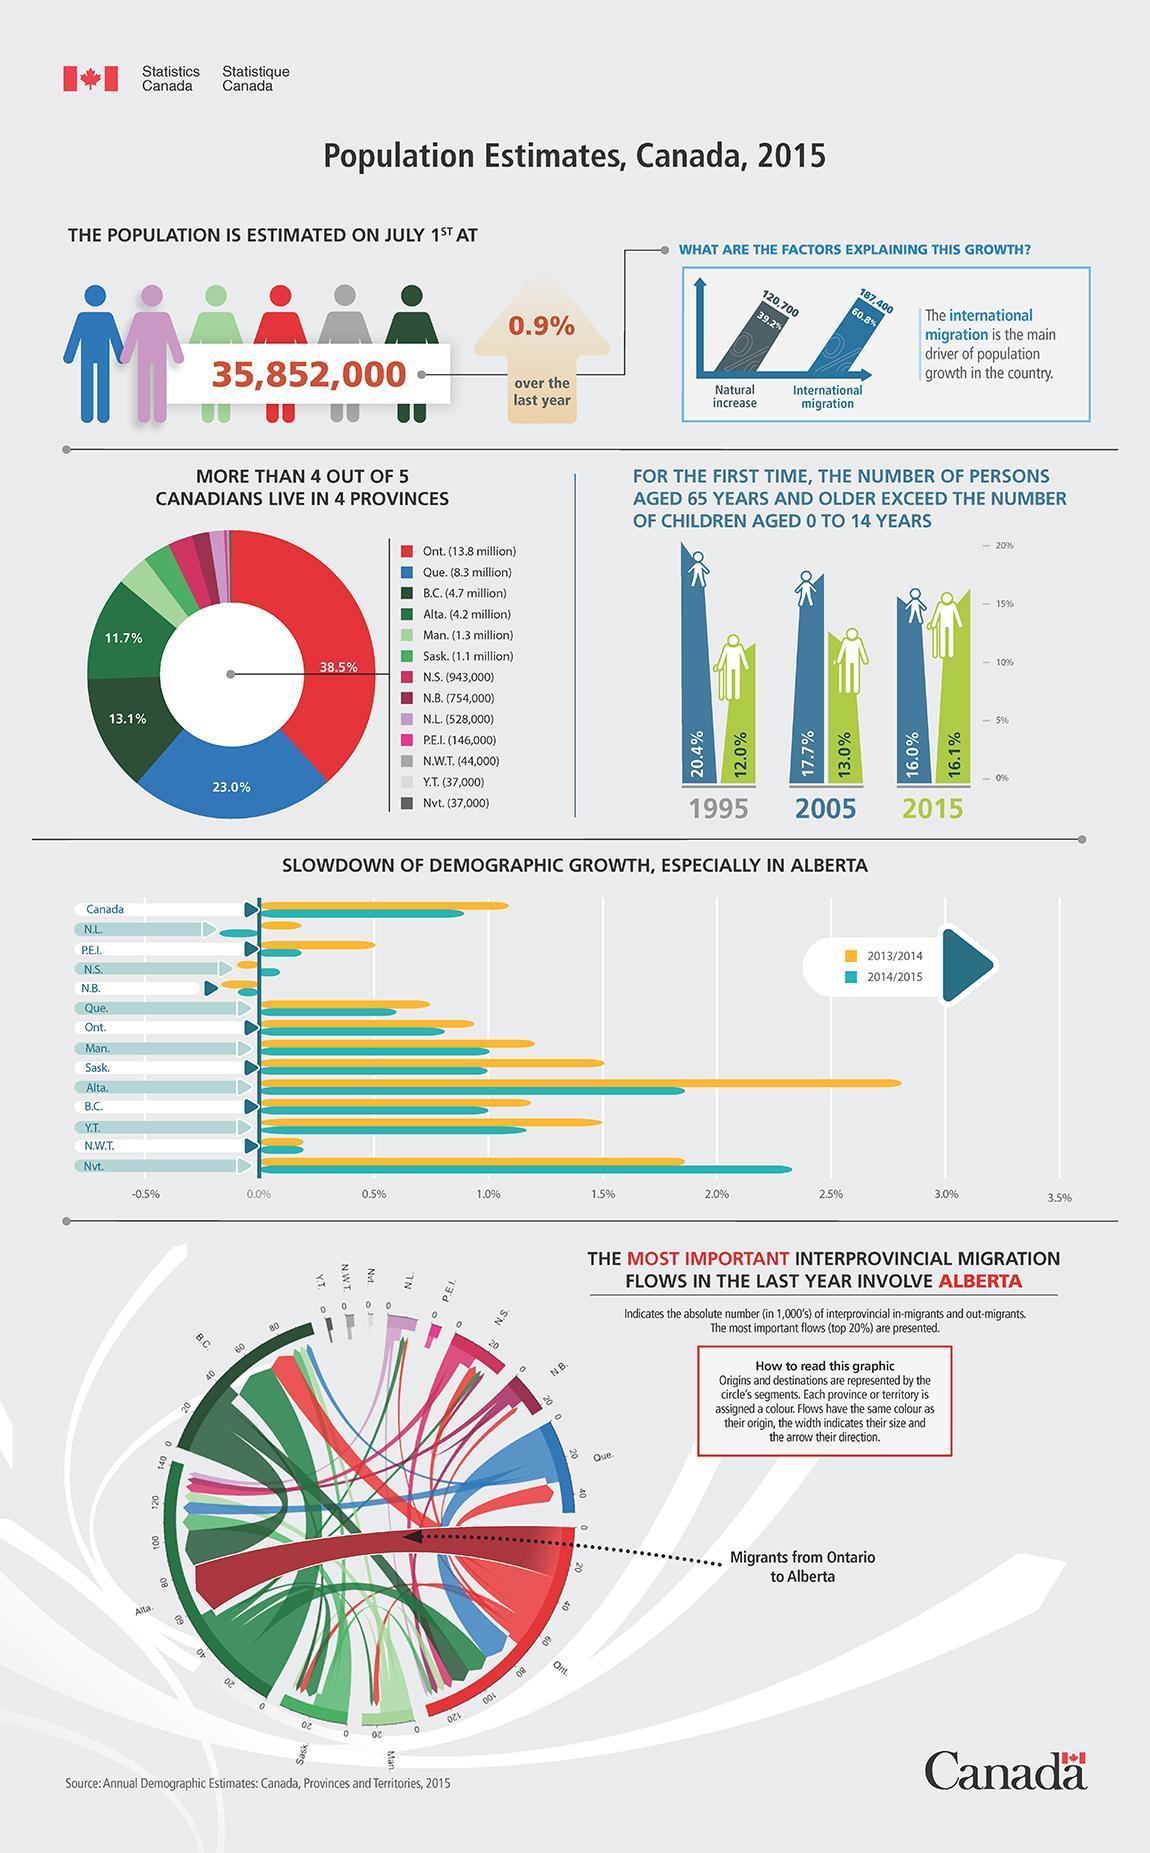What factor is the reason for a growth of 120,700 in the total population?
Answer the question with a short phrase. Natural increase By what percent has the total population increased compared to the previous year? 0.9% What percent of the population live in Ontario? 38.5% What percent was the population of senior citizens in 1995? 12.0% By what percent did population increase due to international immigration? 60.8% What is the estimated population of Canada in 2015? 35,852,000 What percent was the population of children aged 0-14 in 2005? 17.7% In the graph, in which year did the number of senior citizens exceed the number of children below 14 years? 2015 What is the population in millions in the province marked by blue color in the donut chart? 8.3 million Which color is used to represent the province that has the highest population- blue, red or pink? red 